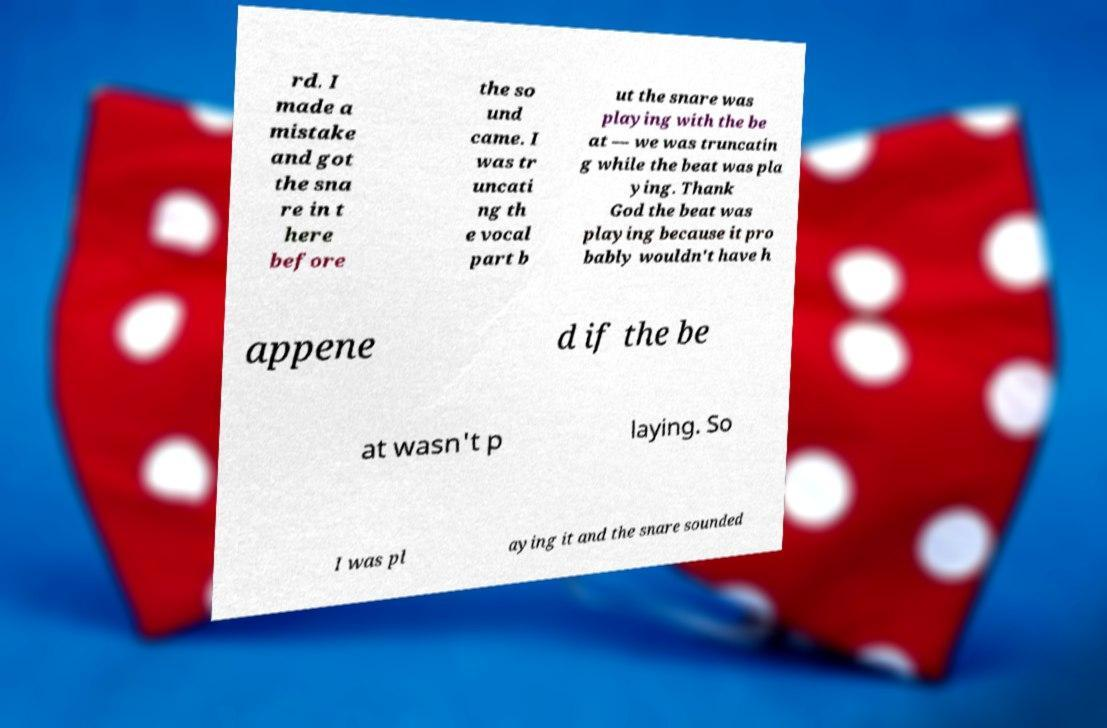For documentation purposes, I need the text within this image transcribed. Could you provide that? rd. I made a mistake and got the sna re in t here before the so und came. I was tr uncati ng th e vocal part b ut the snare was playing with the be at — we was truncatin g while the beat was pla ying. Thank God the beat was playing because it pro bably wouldn't have h appene d if the be at wasn't p laying. So I was pl aying it and the snare sounded 